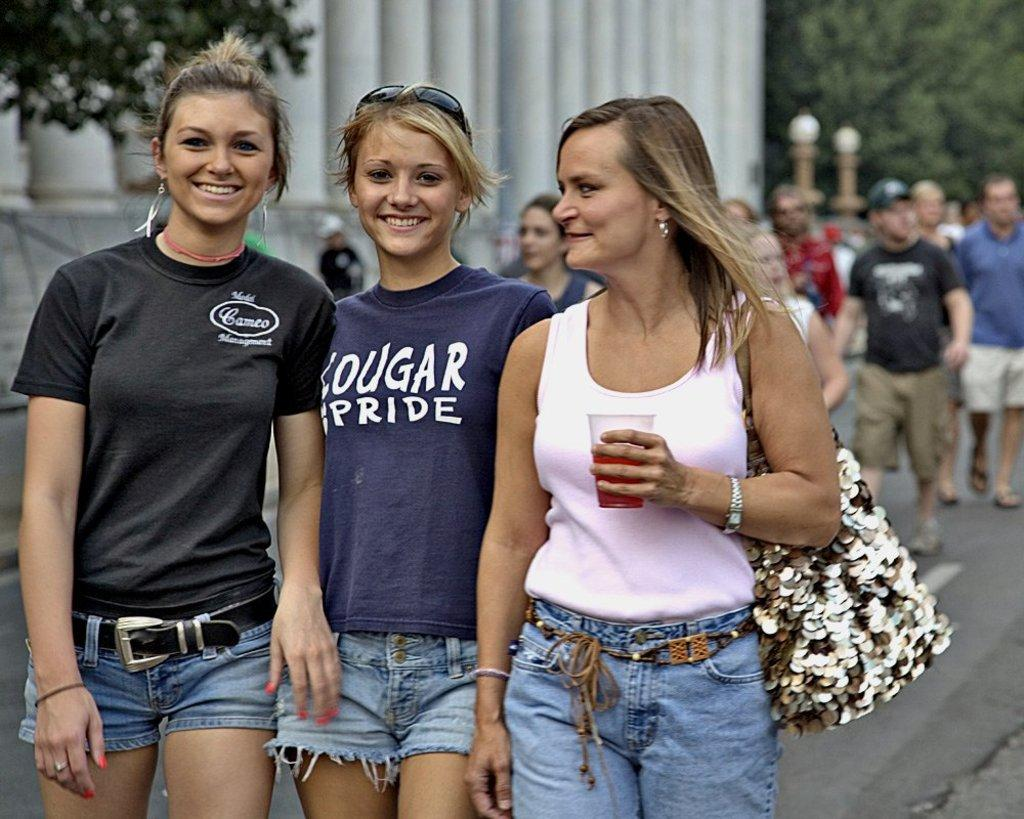How many people are standing in the image? There are three persons standing in the image. What are the people in the image doing? There is a group of people walking on the road in the image. Can you identify any structures in the image? Yes, there is at least one building present in the image. What type of vegetation can be seen in the image? There are trees in the image. What type of note is being played on the guitar in the image? There is no guitar or note present in the image. How does the drain affect the walking group in the image? There is no drain visible in the image, so its effect on the walking group cannot be determined. 